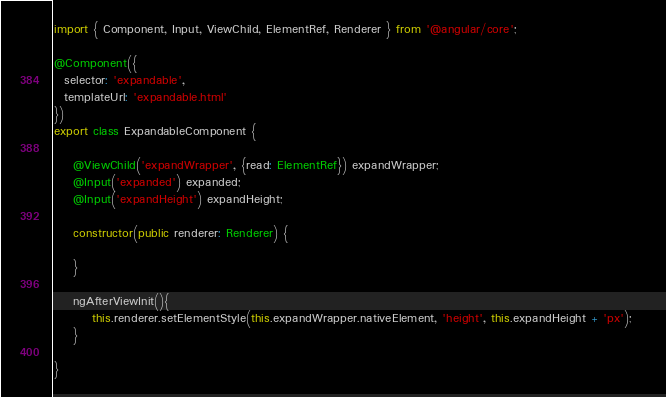<code> <loc_0><loc_0><loc_500><loc_500><_TypeScript_>import { Component, Input, ViewChild, ElementRef, Renderer } from '@angular/core';
 
@Component({
  selector: 'expandable',
  templateUrl: 'expandable.html'
})
export class ExpandableComponent {
 
    @ViewChild('expandWrapper', {read: ElementRef}) expandWrapper;
    @Input('expanded') expanded;
    @Input('expandHeight') expandHeight;
 
    constructor(public renderer: Renderer) {
 
    }
 
    ngAfterViewInit(){
        this.renderer.setElementStyle(this.expandWrapper.nativeElement, 'height', this.expandHeight + 'px');   
    }
 
}</code> 